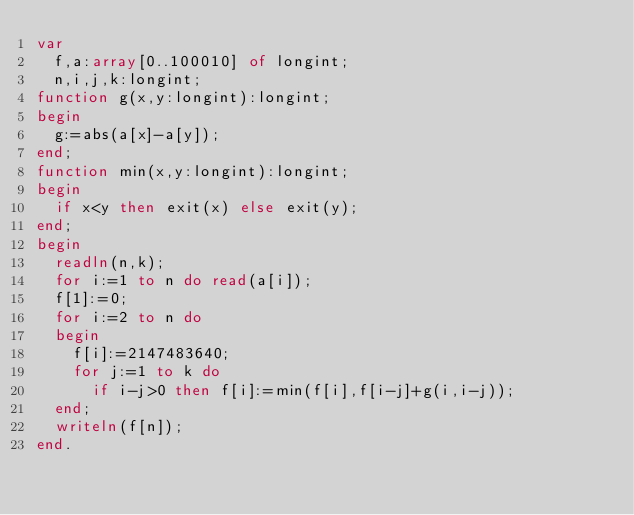<code> <loc_0><loc_0><loc_500><loc_500><_Pascal_>var
	f,a:array[0..100010] of longint;
	n,i,j,k:longint;
function g(x,y:longint):longint;
begin
	g:=abs(a[x]-a[y]);
end;
function min(x,y:longint):longint;
begin
	if x<y then exit(x) else exit(y);
end;
begin
	readln(n,k);
	for i:=1 to n do read(a[i]);
	f[1]:=0;
	for i:=2 to n do
	begin
		f[i]:=2147483640;
		for j:=1 to k do 
			if i-j>0 then f[i]:=min(f[i],f[i-j]+g(i,i-j));
	end;
	writeln(f[n]);
end.</code> 